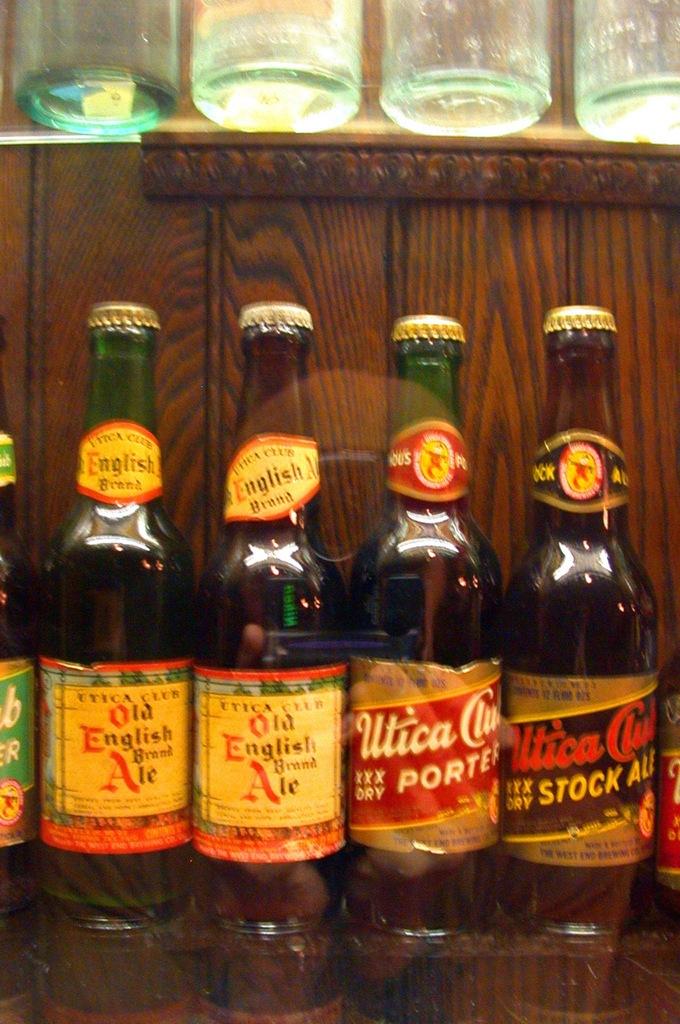What is the name of the drink on the left?
Offer a very short reply. Old english brand ale. 